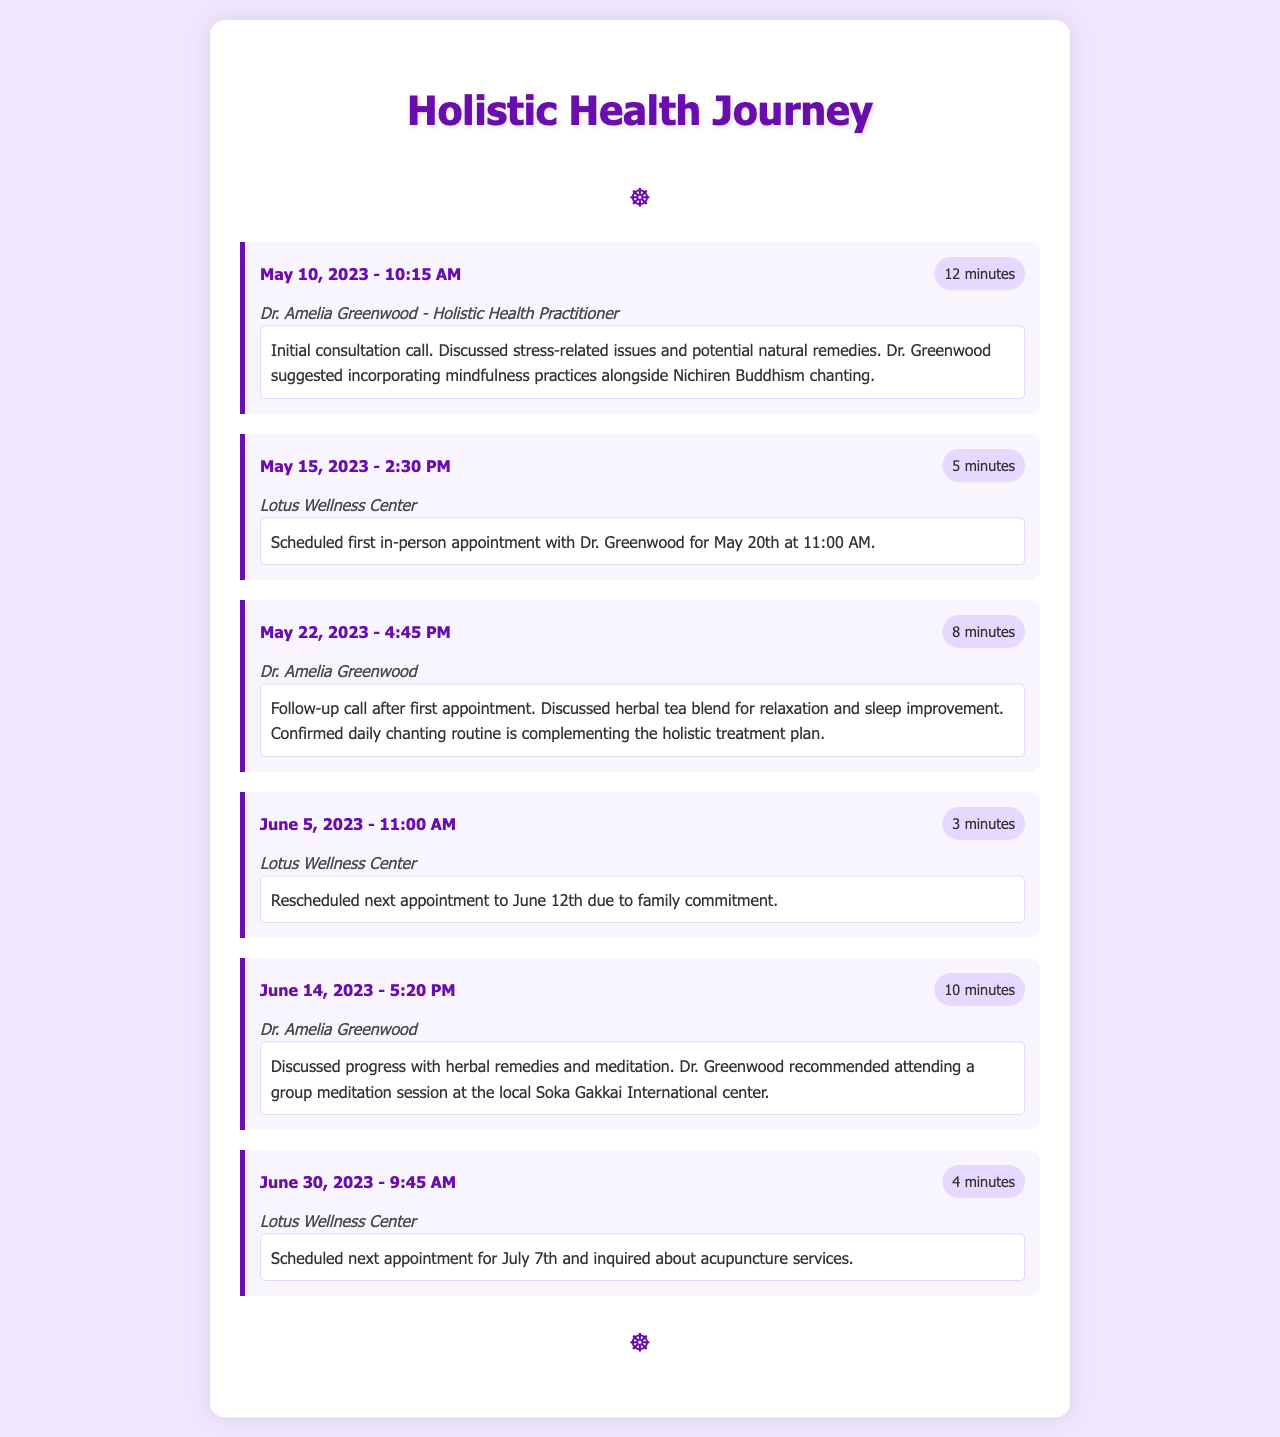What date was the initial consultation call? The initial consultation call took place on May 10, 2023, as noted in the first record.
Answer: May 10, 2023 Who was the health practitioner for the initial consultation? The initial consultation was with Dr. Amelia Greenwood, according to the details provided in the first record.
Answer: Dr. Amelia Greenwood What was discussed during the follow-up call on May 22, 2023? The follow-up call on May 22, 2023, revolved around herbal tea blend for relaxation and the daily chanting routine.
Answer: Herbal tea blend for relaxation When was the next appointment rescheduled to after the June 5, 2023 call? The appointment was rescheduled to June 12th as mentioned in the call with Lotus Wellness Center.
Answer: June 12th How long did the initial consultation call last? The duration of the initial consultation call on May 10, 2023, was 12 minutes.
Answer: 12 minutes What was recommended during the June 14, 2023 call? During the June 14, 2023 call, it was suggested to attend a group meditation session at the local center.
Answer: Group meditation session Which service was inquired about during the June 30, 2023 call? The inquiry during the June 30, 2023 call was about acupuncture services.
Answer: Acupuncture services 